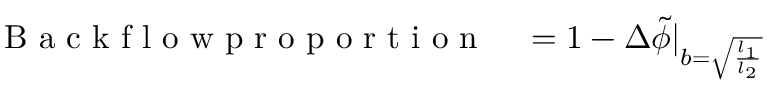<formula> <loc_0><loc_0><loc_500><loc_500>\begin{array} { r l } { B a c k f l o w p r o p o r t i o n } & = 1 - \Delta \tilde { \phi } | _ { b = \sqrt { \frac { l _ { 1 } } { l _ { 2 } } } } } \end{array}</formula> 